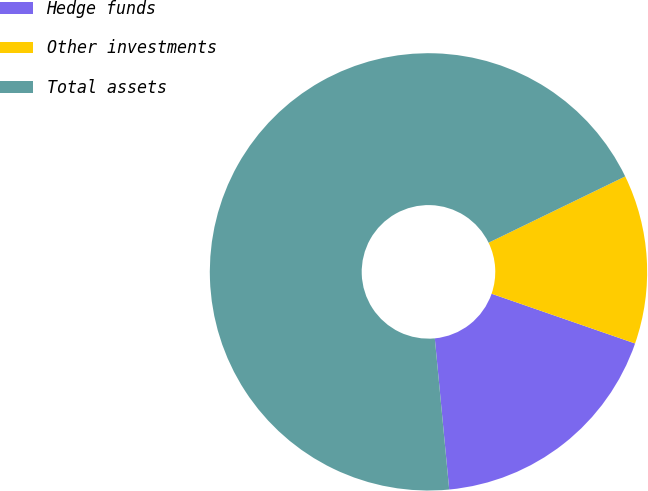Convert chart. <chart><loc_0><loc_0><loc_500><loc_500><pie_chart><fcel>Hedge funds<fcel>Other investments<fcel>Total assets<nl><fcel>18.18%<fcel>12.5%<fcel>69.32%<nl></chart> 